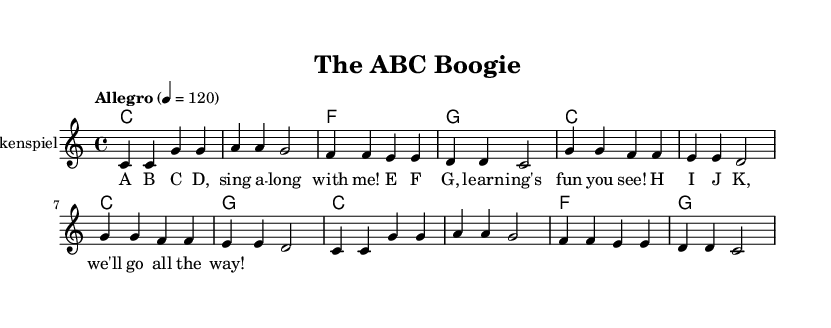What is the key signature of this music? The key signature is C major, which consists of no sharps or flats indicated at the beginning of the staff.
Answer: C major What is the time signature of this music? The time signature is indicated as 4/4, which means there are four beats in each measure and the quarter note gets one beat.
Answer: 4/4 What is the tempo marking for this piece? The tempo is marked as "Allegro" and specifies a speed of 120 beats per minute, indicating a lively and fast-paced performance.
Answer: Allegro, 120 How many measures are in the melody? The melody consists of 8 measures, as counted from the beginning to the end of the melody section, with each complete set of notes between the bar lines representing a measure.
Answer: 8 What is the main theme of the lyrics? The main theme of the lyrics revolves around singing the alphabet, emphasizing learning and having fun together, as illustrated by the letter progression presented in the lyrics.
Answer: Alphabet What is the instrument for the melody? The instrument specified for the melody is the Glockenspiel, which is a percussion instrument typically made of metal bars and played with mallets, contributing to a bright and cheerful sound appropriate for children's music.
Answer: Glockenspiel How many unique chords are identified in the harmonies? There are three unique chords identified in the harmonies section: C, F, and G, which repeat throughout the piece. The chords help to provide musical support and structure to the melody.
Answer: Three 